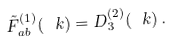Convert formula to latex. <formula><loc_0><loc_0><loc_500><loc_500>\tilde { F } _ { a b } ^ { ( 1 ) } ( \ k ) = D _ { 3 } ^ { ( 2 ) } ( \ k ) \, .</formula> 